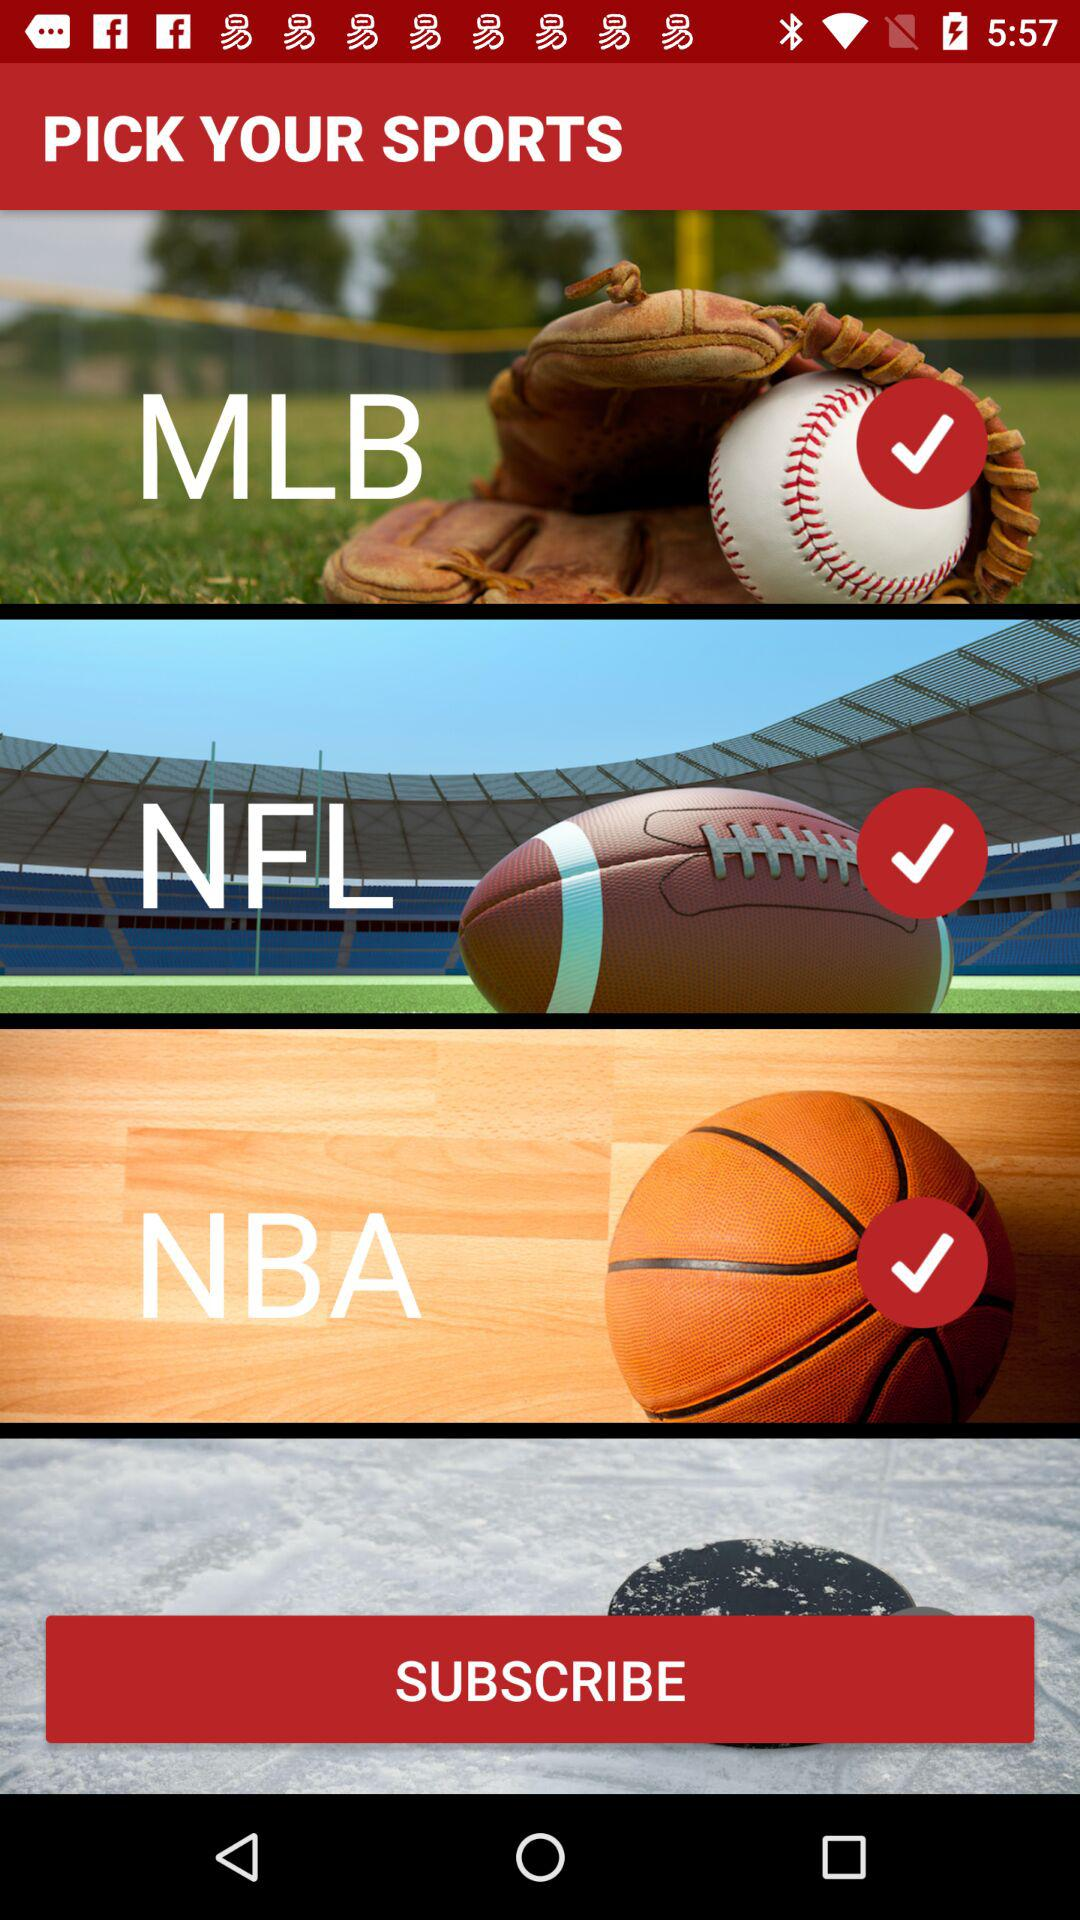Is NHL selected?
When the provided information is insufficient, respond with <no answer>. <no answer> 